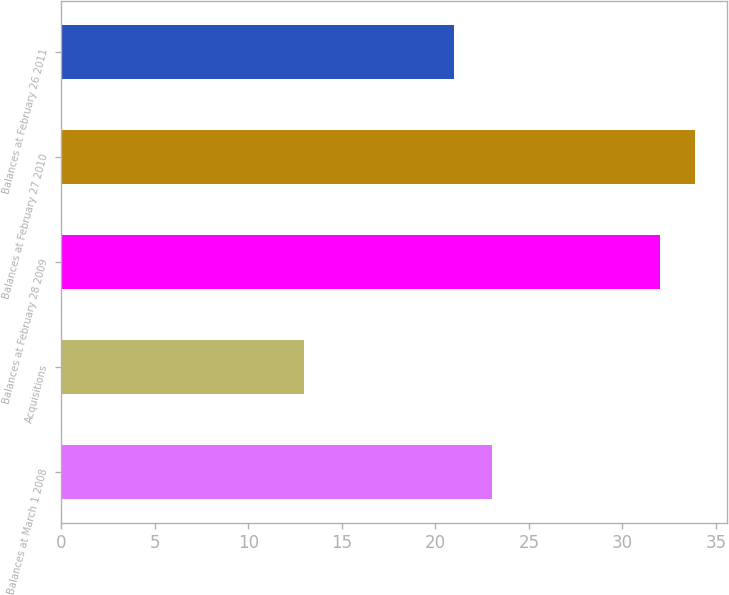Convert chart. <chart><loc_0><loc_0><loc_500><loc_500><bar_chart><fcel>Balances at March 1 2008<fcel>Acquisitions<fcel>Balances at February 28 2009<fcel>Balances at February 27 2010<fcel>Balances at February 26 2011<nl><fcel>23<fcel>13<fcel>32<fcel>33.9<fcel>21<nl></chart> 